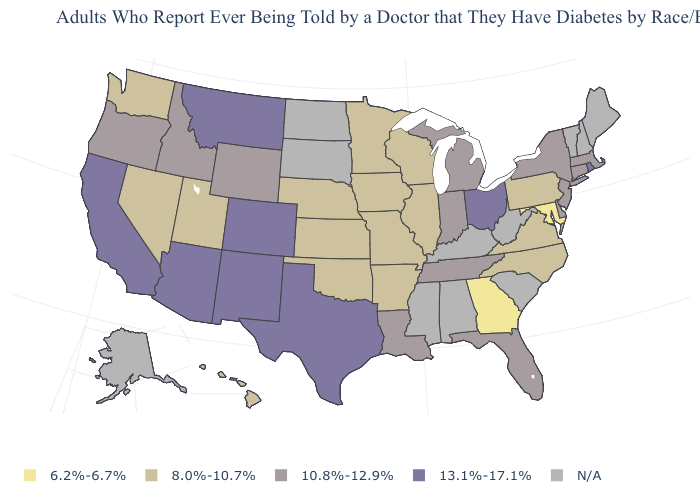What is the lowest value in the MidWest?
Write a very short answer. 8.0%-10.7%. What is the value of Arkansas?
Be succinct. 8.0%-10.7%. What is the highest value in the USA?
Be succinct. 13.1%-17.1%. What is the value of Iowa?
Short answer required. 8.0%-10.7%. What is the value of Colorado?
Short answer required. 13.1%-17.1%. Which states hav the highest value in the Northeast?
Concise answer only. Rhode Island. What is the value of West Virginia?
Short answer required. N/A. Name the states that have a value in the range 13.1%-17.1%?
Write a very short answer. Arizona, California, Colorado, Montana, New Mexico, Ohio, Rhode Island, Texas. What is the highest value in the Northeast ?
Keep it brief. 13.1%-17.1%. Which states hav the highest value in the South?
Be succinct. Texas. Which states have the lowest value in the MidWest?
Write a very short answer. Illinois, Iowa, Kansas, Minnesota, Missouri, Nebraska, Wisconsin. What is the value of Louisiana?
Keep it brief. 10.8%-12.9%. Does Tennessee have the highest value in the South?
Give a very brief answer. No. Name the states that have a value in the range 10.8%-12.9%?
Write a very short answer. Connecticut, Delaware, Florida, Idaho, Indiana, Louisiana, Massachusetts, Michigan, New Jersey, New York, Oregon, Tennessee, Wyoming. 